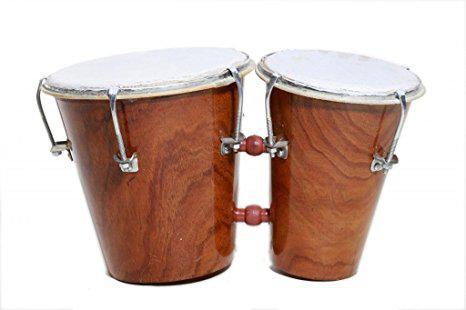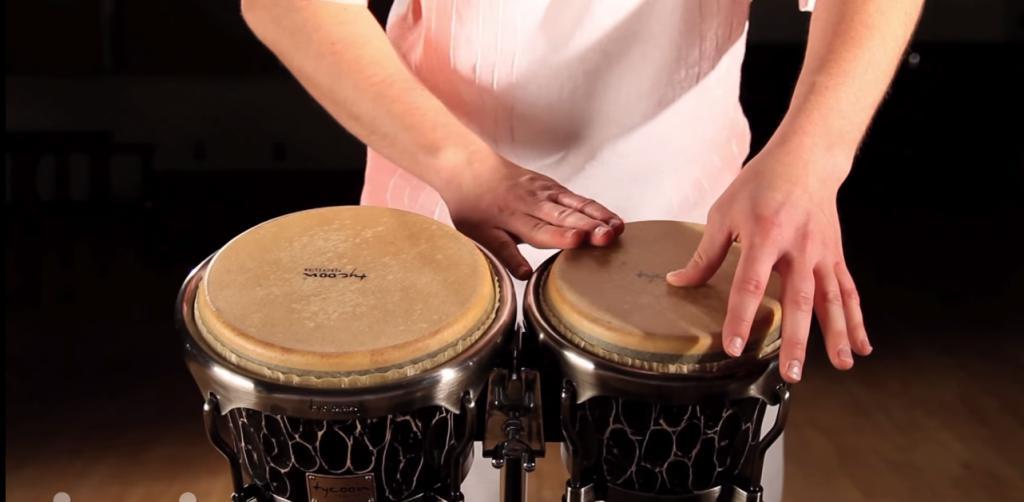The first image is the image on the left, the second image is the image on the right. For the images displayed, is the sentence "There are exactly two pairs of bongo drums." factually correct? Answer yes or no. Yes. The first image is the image on the left, the second image is the image on the right. Evaluate the accuracy of this statement regarding the images: "Each image shows a connected pair of drums, and one image features wood grain drums without a footed stand.". Is it true? Answer yes or no. Yes. 